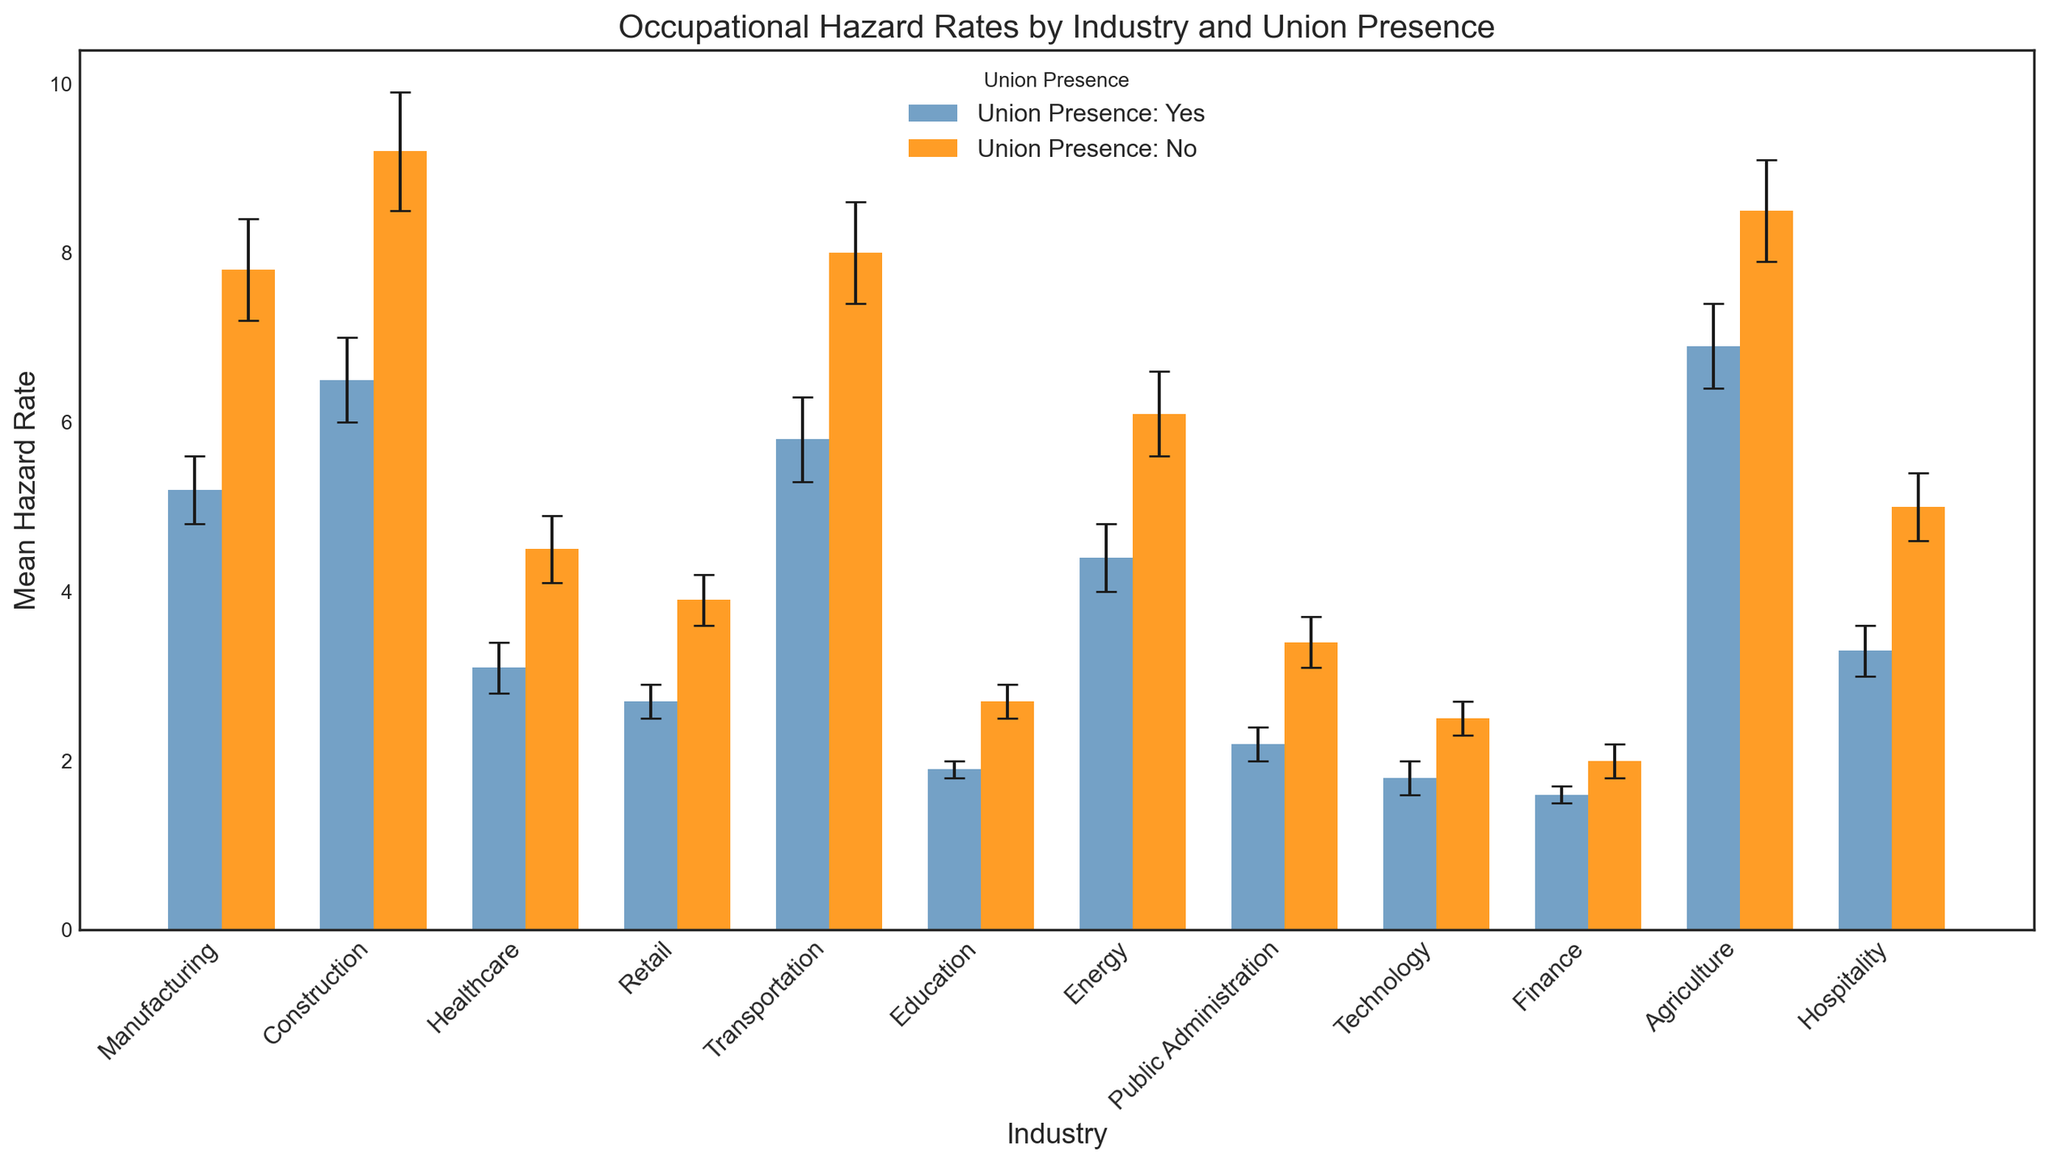What's the difference in the mean hazard rate between Manufacturing with and without union presence? The mean hazard rate for Manufacturing with union presence is 5.2, and without union presence is 7.8. Subtract the former from the latter: 7.8 - 5.2 = 2.6
Answer: 2.6 Which industry has the lowest mean hazard rate with union presence? Look at the "Mean Hazard Rate" values for all industries with union presence. The lowest value is for Finance, which is 1.6.
Answer: Finance In which industry does union presence result in the greatest reduction in mean hazard rate? Calculate the difference in mean hazard rate for each industry with and without union presence. The differences are: Manufacturing (2.6), Construction (2.7), Healthcare (1.4), Retail (1.2), Transportation (2.2), Education (0.8), Energy (1.7), Public Administration (1.2), Technology (0.7), Finance (0.4), Agriculture (1.6), Hospitality (1.7). The greatest reduction is in Construction (2.7).
Answer: Construction How many industries have a mean hazard rate greater than 5 when union presence is "Yes"? Look at the "Mean Hazard Rate" values for each industry with union presence. The industries with values greater than 5 are Manufacturing, Construction, Transportation, and Agriculture. There are 4 industries.
Answer: 4 For Retail, what is the difference in the error bar heights for union presence vs. no union presence? The standard error for Retail with union presence is 0.2, and without union presence is 0.3. The difference is 0.3 - 0.2 = 0.1
Answer: 0.1 